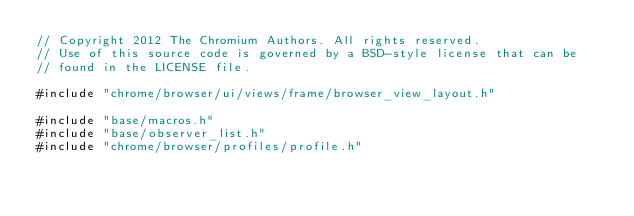Convert code to text. <code><loc_0><loc_0><loc_500><loc_500><_C++_>// Copyright 2012 The Chromium Authors. All rights reserved.
// Use of this source code is governed by a BSD-style license that can be
// found in the LICENSE file.

#include "chrome/browser/ui/views/frame/browser_view_layout.h"

#include "base/macros.h"
#include "base/observer_list.h"
#include "chrome/browser/profiles/profile.h"</code> 